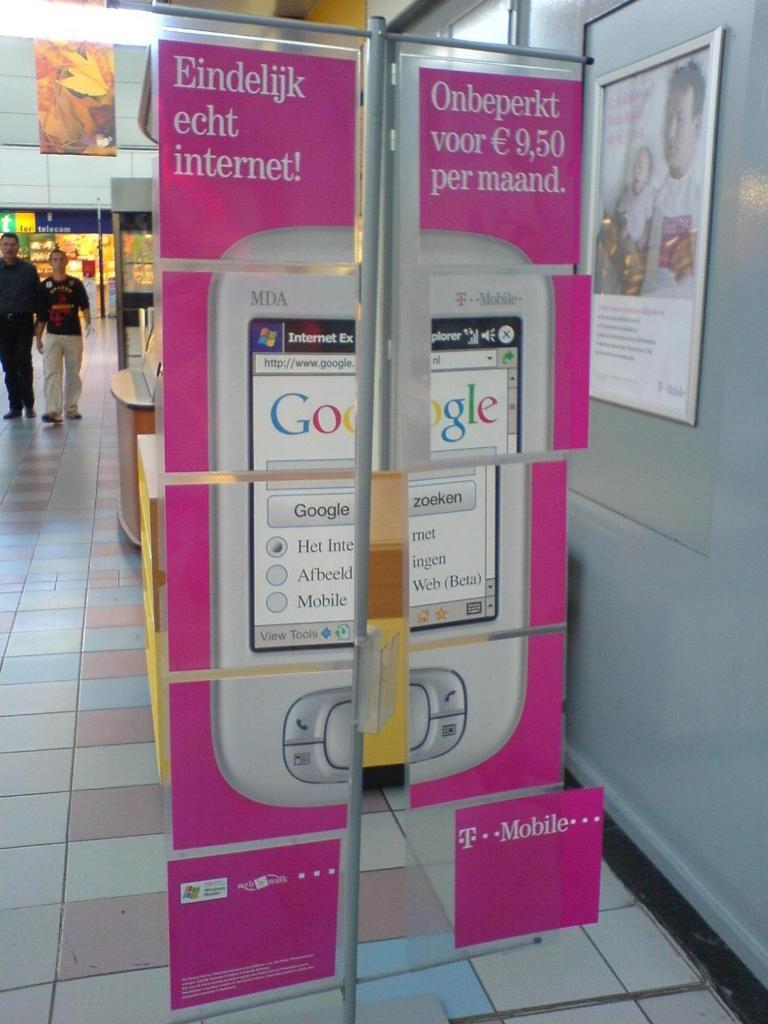<image>
Create a compact narrative representing the image presented. a big ad in a mall for MDA phone from T Mobile on a pink backdrop 